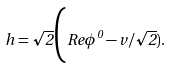Convert formula to latex. <formula><loc_0><loc_0><loc_500><loc_500>h = \sqrt { 2 } \Big ( R e \phi ^ { 0 } - v / \sqrt { 2 } ) .</formula> 